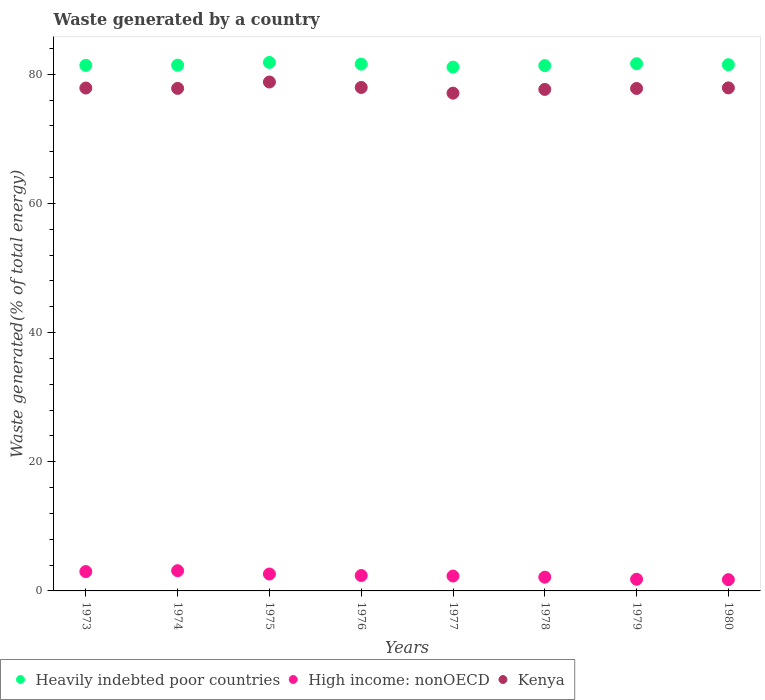How many different coloured dotlines are there?
Your response must be concise. 3. What is the total waste generated in High income: nonOECD in 1973?
Offer a terse response. 2.99. Across all years, what is the maximum total waste generated in Heavily indebted poor countries?
Provide a short and direct response. 81.84. Across all years, what is the minimum total waste generated in Kenya?
Ensure brevity in your answer.  77.08. In which year was the total waste generated in Heavily indebted poor countries maximum?
Provide a short and direct response. 1975. What is the total total waste generated in Kenya in the graph?
Your answer should be compact. 622.92. What is the difference between the total waste generated in High income: nonOECD in 1978 and that in 1980?
Ensure brevity in your answer.  0.38. What is the difference between the total waste generated in Heavily indebted poor countries in 1979 and the total waste generated in High income: nonOECD in 1976?
Keep it short and to the point. 79.26. What is the average total waste generated in Heavily indebted poor countries per year?
Make the answer very short. 81.48. In the year 1975, what is the difference between the total waste generated in Heavily indebted poor countries and total waste generated in Kenya?
Offer a terse response. 3.03. In how many years, is the total waste generated in Kenya greater than 12 %?
Your answer should be very brief. 8. What is the ratio of the total waste generated in Heavily indebted poor countries in 1973 to that in 1975?
Give a very brief answer. 0.99. What is the difference between the highest and the second highest total waste generated in Kenya?
Your response must be concise. 0.84. What is the difference between the highest and the lowest total waste generated in Kenya?
Give a very brief answer. 1.73. Is the sum of the total waste generated in Kenya in 1977 and 1978 greater than the maximum total waste generated in Heavily indebted poor countries across all years?
Your response must be concise. Yes. Is it the case that in every year, the sum of the total waste generated in Heavily indebted poor countries and total waste generated in High income: nonOECD  is greater than the total waste generated in Kenya?
Your response must be concise. Yes. Does the total waste generated in High income: nonOECD monotonically increase over the years?
Provide a succinct answer. No. Is the total waste generated in High income: nonOECD strictly greater than the total waste generated in Heavily indebted poor countries over the years?
Offer a very short reply. No. Is the total waste generated in High income: nonOECD strictly less than the total waste generated in Heavily indebted poor countries over the years?
Offer a terse response. Yes. How many dotlines are there?
Offer a terse response. 3. Where does the legend appear in the graph?
Give a very brief answer. Bottom left. How many legend labels are there?
Your answer should be compact. 3. What is the title of the graph?
Your answer should be very brief. Waste generated by a country. Does "Fragile and conflict affected situations" appear as one of the legend labels in the graph?
Offer a terse response. No. What is the label or title of the Y-axis?
Provide a succinct answer. Waste generated(% of total energy). What is the Waste generated(% of total energy) of Heavily indebted poor countries in 1973?
Provide a succinct answer. 81.39. What is the Waste generated(% of total energy) of High income: nonOECD in 1973?
Ensure brevity in your answer.  2.99. What is the Waste generated(% of total energy) of Kenya in 1973?
Make the answer very short. 77.88. What is the Waste generated(% of total energy) of Heavily indebted poor countries in 1974?
Keep it short and to the point. 81.42. What is the Waste generated(% of total energy) in High income: nonOECD in 1974?
Your answer should be compact. 3.13. What is the Waste generated(% of total energy) in Kenya in 1974?
Give a very brief answer. 77.82. What is the Waste generated(% of total energy) of Heavily indebted poor countries in 1975?
Keep it short and to the point. 81.84. What is the Waste generated(% of total energy) in High income: nonOECD in 1975?
Ensure brevity in your answer.  2.62. What is the Waste generated(% of total energy) in Kenya in 1975?
Keep it short and to the point. 78.81. What is the Waste generated(% of total energy) in Heavily indebted poor countries in 1976?
Offer a very short reply. 81.58. What is the Waste generated(% of total energy) of High income: nonOECD in 1976?
Offer a terse response. 2.38. What is the Waste generated(% of total energy) of Kenya in 1976?
Provide a succinct answer. 77.97. What is the Waste generated(% of total energy) of Heavily indebted poor countries in 1977?
Ensure brevity in your answer.  81.11. What is the Waste generated(% of total energy) of High income: nonOECD in 1977?
Your answer should be compact. 2.3. What is the Waste generated(% of total energy) in Kenya in 1977?
Make the answer very short. 77.08. What is the Waste generated(% of total energy) of Heavily indebted poor countries in 1978?
Keep it short and to the point. 81.35. What is the Waste generated(% of total energy) in High income: nonOECD in 1978?
Keep it short and to the point. 2.13. What is the Waste generated(% of total energy) in Kenya in 1978?
Your answer should be very brief. 77.66. What is the Waste generated(% of total energy) in Heavily indebted poor countries in 1979?
Offer a very short reply. 81.64. What is the Waste generated(% of total energy) of High income: nonOECD in 1979?
Give a very brief answer. 1.8. What is the Waste generated(% of total energy) in Kenya in 1979?
Provide a succinct answer. 77.81. What is the Waste generated(% of total energy) of Heavily indebted poor countries in 1980?
Ensure brevity in your answer.  81.49. What is the Waste generated(% of total energy) of High income: nonOECD in 1980?
Ensure brevity in your answer.  1.75. What is the Waste generated(% of total energy) in Kenya in 1980?
Provide a succinct answer. 77.9. Across all years, what is the maximum Waste generated(% of total energy) of Heavily indebted poor countries?
Your response must be concise. 81.84. Across all years, what is the maximum Waste generated(% of total energy) of High income: nonOECD?
Your response must be concise. 3.13. Across all years, what is the maximum Waste generated(% of total energy) in Kenya?
Keep it short and to the point. 78.81. Across all years, what is the minimum Waste generated(% of total energy) of Heavily indebted poor countries?
Make the answer very short. 81.11. Across all years, what is the minimum Waste generated(% of total energy) of High income: nonOECD?
Give a very brief answer. 1.75. Across all years, what is the minimum Waste generated(% of total energy) in Kenya?
Provide a short and direct response. 77.08. What is the total Waste generated(% of total energy) in Heavily indebted poor countries in the graph?
Offer a very short reply. 651.8. What is the total Waste generated(% of total energy) of High income: nonOECD in the graph?
Give a very brief answer. 19.11. What is the total Waste generated(% of total energy) in Kenya in the graph?
Provide a succinct answer. 622.92. What is the difference between the Waste generated(% of total energy) in Heavily indebted poor countries in 1973 and that in 1974?
Your answer should be very brief. -0.03. What is the difference between the Waste generated(% of total energy) of High income: nonOECD in 1973 and that in 1974?
Keep it short and to the point. -0.14. What is the difference between the Waste generated(% of total energy) of Kenya in 1973 and that in 1974?
Make the answer very short. 0.06. What is the difference between the Waste generated(% of total energy) in Heavily indebted poor countries in 1973 and that in 1975?
Make the answer very short. -0.45. What is the difference between the Waste generated(% of total energy) in High income: nonOECD in 1973 and that in 1975?
Offer a very short reply. 0.38. What is the difference between the Waste generated(% of total energy) in Kenya in 1973 and that in 1975?
Your answer should be compact. -0.93. What is the difference between the Waste generated(% of total energy) in Heavily indebted poor countries in 1973 and that in 1976?
Your answer should be compact. -0.19. What is the difference between the Waste generated(% of total energy) in High income: nonOECD in 1973 and that in 1976?
Offer a very short reply. 0.61. What is the difference between the Waste generated(% of total energy) in Kenya in 1973 and that in 1976?
Provide a short and direct response. -0.09. What is the difference between the Waste generated(% of total energy) in Heavily indebted poor countries in 1973 and that in 1977?
Your answer should be very brief. 0.27. What is the difference between the Waste generated(% of total energy) of High income: nonOECD in 1973 and that in 1977?
Keep it short and to the point. 0.69. What is the difference between the Waste generated(% of total energy) of Kenya in 1973 and that in 1977?
Give a very brief answer. 0.8. What is the difference between the Waste generated(% of total energy) in Heavily indebted poor countries in 1973 and that in 1978?
Your answer should be very brief. 0.04. What is the difference between the Waste generated(% of total energy) of High income: nonOECD in 1973 and that in 1978?
Ensure brevity in your answer.  0.87. What is the difference between the Waste generated(% of total energy) of Kenya in 1973 and that in 1978?
Offer a terse response. 0.22. What is the difference between the Waste generated(% of total energy) of Heavily indebted poor countries in 1973 and that in 1979?
Your response must be concise. -0.26. What is the difference between the Waste generated(% of total energy) of High income: nonOECD in 1973 and that in 1979?
Provide a succinct answer. 1.19. What is the difference between the Waste generated(% of total energy) of Kenya in 1973 and that in 1979?
Your response must be concise. 0.07. What is the difference between the Waste generated(% of total energy) of Heavily indebted poor countries in 1973 and that in 1980?
Ensure brevity in your answer.  -0.1. What is the difference between the Waste generated(% of total energy) in High income: nonOECD in 1973 and that in 1980?
Ensure brevity in your answer.  1.25. What is the difference between the Waste generated(% of total energy) of Kenya in 1973 and that in 1980?
Your answer should be compact. -0.02. What is the difference between the Waste generated(% of total energy) of Heavily indebted poor countries in 1974 and that in 1975?
Make the answer very short. -0.42. What is the difference between the Waste generated(% of total energy) in High income: nonOECD in 1974 and that in 1975?
Offer a very short reply. 0.51. What is the difference between the Waste generated(% of total energy) of Kenya in 1974 and that in 1975?
Ensure brevity in your answer.  -0.99. What is the difference between the Waste generated(% of total energy) in Heavily indebted poor countries in 1974 and that in 1976?
Give a very brief answer. -0.16. What is the difference between the Waste generated(% of total energy) in Kenya in 1974 and that in 1976?
Your answer should be very brief. -0.15. What is the difference between the Waste generated(% of total energy) of Heavily indebted poor countries in 1974 and that in 1977?
Make the answer very short. 0.3. What is the difference between the Waste generated(% of total energy) of High income: nonOECD in 1974 and that in 1977?
Offer a very short reply. 0.83. What is the difference between the Waste generated(% of total energy) in Kenya in 1974 and that in 1977?
Provide a succinct answer. 0.74. What is the difference between the Waste generated(% of total energy) of Heavily indebted poor countries in 1974 and that in 1978?
Keep it short and to the point. 0.07. What is the difference between the Waste generated(% of total energy) of High income: nonOECD in 1974 and that in 1978?
Your response must be concise. 1. What is the difference between the Waste generated(% of total energy) of Kenya in 1974 and that in 1978?
Provide a short and direct response. 0.16. What is the difference between the Waste generated(% of total energy) of Heavily indebted poor countries in 1974 and that in 1979?
Keep it short and to the point. -0.23. What is the difference between the Waste generated(% of total energy) in High income: nonOECD in 1974 and that in 1979?
Provide a short and direct response. 1.33. What is the difference between the Waste generated(% of total energy) of Kenya in 1974 and that in 1979?
Give a very brief answer. 0.01. What is the difference between the Waste generated(% of total energy) of Heavily indebted poor countries in 1974 and that in 1980?
Keep it short and to the point. -0.07. What is the difference between the Waste generated(% of total energy) in High income: nonOECD in 1974 and that in 1980?
Provide a short and direct response. 1.39. What is the difference between the Waste generated(% of total energy) of Kenya in 1974 and that in 1980?
Make the answer very short. -0.08. What is the difference between the Waste generated(% of total energy) in Heavily indebted poor countries in 1975 and that in 1976?
Offer a terse response. 0.26. What is the difference between the Waste generated(% of total energy) in High income: nonOECD in 1975 and that in 1976?
Provide a succinct answer. 0.24. What is the difference between the Waste generated(% of total energy) of Kenya in 1975 and that in 1976?
Offer a very short reply. 0.84. What is the difference between the Waste generated(% of total energy) in Heavily indebted poor countries in 1975 and that in 1977?
Give a very brief answer. 0.73. What is the difference between the Waste generated(% of total energy) in High income: nonOECD in 1975 and that in 1977?
Give a very brief answer. 0.31. What is the difference between the Waste generated(% of total energy) in Kenya in 1975 and that in 1977?
Provide a short and direct response. 1.73. What is the difference between the Waste generated(% of total energy) of Heavily indebted poor countries in 1975 and that in 1978?
Ensure brevity in your answer.  0.49. What is the difference between the Waste generated(% of total energy) of High income: nonOECD in 1975 and that in 1978?
Ensure brevity in your answer.  0.49. What is the difference between the Waste generated(% of total energy) of Kenya in 1975 and that in 1978?
Offer a very short reply. 1.15. What is the difference between the Waste generated(% of total energy) of Heavily indebted poor countries in 1975 and that in 1979?
Your response must be concise. 0.2. What is the difference between the Waste generated(% of total energy) in High income: nonOECD in 1975 and that in 1979?
Provide a short and direct response. 0.82. What is the difference between the Waste generated(% of total energy) of Heavily indebted poor countries in 1975 and that in 1980?
Offer a very short reply. 0.35. What is the difference between the Waste generated(% of total energy) in High income: nonOECD in 1975 and that in 1980?
Your answer should be very brief. 0.87. What is the difference between the Waste generated(% of total energy) in Kenya in 1975 and that in 1980?
Make the answer very short. 0.91. What is the difference between the Waste generated(% of total energy) in Heavily indebted poor countries in 1976 and that in 1977?
Provide a succinct answer. 0.46. What is the difference between the Waste generated(% of total energy) of High income: nonOECD in 1976 and that in 1977?
Provide a short and direct response. 0.08. What is the difference between the Waste generated(% of total energy) of Kenya in 1976 and that in 1977?
Make the answer very short. 0.88. What is the difference between the Waste generated(% of total energy) in Heavily indebted poor countries in 1976 and that in 1978?
Provide a succinct answer. 0.23. What is the difference between the Waste generated(% of total energy) of High income: nonOECD in 1976 and that in 1978?
Offer a terse response. 0.25. What is the difference between the Waste generated(% of total energy) of Kenya in 1976 and that in 1978?
Your answer should be compact. 0.3. What is the difference between the Waste generated(% of total energy) in Heavily indebted poor countries in 1976 and that in 1979?
Provide a short and direct response. -0.07. What is the difference between the Waste generated(% of total energy) of High income: nonOECD in 1976 and that in 1979?
Provide a short and direct response. 0.58. What is the difference between the Waste generated(% of total energy) in Kenya in 1976 and that in 1979?
Give a very brief answer. 0.16. What is the difference between the Waste generated(% of total energy) in Heavily indebted poor countries in 1976 and that in 1980?
Keep it short and to the point. 0.09. What is the difference between the Waste generated(% of total energy) in High income: nonOECD in 1976 and that in 1980?
Make the answer very short. 0.64. What is the difference between the Waste generated(% of total energy) of Kenya in 1976 and that in 1980?
Offer a terse response. 0.07. What is the difference between the Waste generated(% of total energy) in Heavily indebted poor countries in 1977 and that in 1978?
Make the answer very short. -0.24. What is the difference between the Waste generated(% of total energy) of High income: nonOECD in 1977 and that in 1978?
Your response must be concise. 0.18. What is the difference between the Waste generated(% of total energy) of Kenya in 1977 and that in 1978?
Your response must be concise. -0.58. What is the difference between the Waste generated(% of total energy) in Heavily indebted poor countries in 1977 and that in 1979?
Keep it short and to the point. -0.53. What is the difference between the Waste generated(% of total energy) in High income: nonOECD in 1977 and that in 1979?
Your answer should be very brief. 0.5. What is the difference between the Waste generated(% of total energy) in Kenya in 1977 and that in 1979?
Offer a very short reply. -0.73. What is the difference between the Waste generated(% of total energy) of Heavily indebted poor countries in 1977 and that in 1980?
Offer a terse response. -0.37. What is the difference between the Waste generated(% of total energy) in High income: nonOECD in 1977 and that in 1980?
Your answer should be compact. 0.56. What is the difference between the Waste generated(% of total energy) in Kenya in 1977 and that in 1980?
Your answer should be very brief. -0.82. What is the difference between the Waste generated(% of total energy) in Heavily indebted poor countries in 1978 and that in 1979?
Your answer should be very brief. -0.29. What is the difference between the Waste generated(% of total energy) in High income: nonOECD in 1978 and that in 1979?
Give a very brief answer. 0.33. What is the difference between the Waste generated(% of total energy) in Kenya in 1978 and that in 1979?
Provide a short and direct response. -0.15. What is the difference between the Waste generated(% of total energy) of Heavily indebted poor countries in 1978 and that in 1980?
Offer a terse response. -0.14. What is the difference between the Waste generated(% of total energy) of High income: nonOECD in 1978 and that in 1980?
Make the answer very short. 0.38. What is the difference between the Waste generated(% of total energy) of Kenya in 1978 and that in 1980?
Make the answer very short. -0.24. What is the difference between the Waste generated(% of total energy) in Heavily indebted poor countries in 1979 and that in 1980?
Your response must be concise. 0.15. What is the difference between the Waste generated(% of total energy) in High income: nonOECD in 1979 and that in 1980?
Keep it short and to the point. 0.05. What is the difference between the Waste generated(% of total energy) in Kenya in 1979 and that in 1980?
Keep it short and to the point. -0.09. What is the difference between the Waste generated(% of total energy) in Heavily indebted poor countries in 1973 and the Waste generated(% of total energy) in High income: nonOECD in 1974?
Your response must be concise. 78.25. What is the difference between the Waste generated(% of total energy) of Heavily indebted poor countries in 1973 and the Waste generated(% of total energy) of Kenya in 1974?
Your response must be concise. 3.57. What is the difference between the Waste generated(% of total energy) of High income: nonOECD in 1973 and the Waste generated(% of total energy) of Kenya in 1974?
Ensure brevity in your answer.  -74.82. What is the difference between the Waste generated(% of total energy) in Heavily indebted poor countries in 1973 and the Waste generated(% of total energy) in High income: nonOECD in 1975?
Your answer should be compact. 78.77. What is the difference between the Waste generated(% of total energy) of Heavily indebted poor countries in 1973 and the Waste generated(% of total energy) of Kenya in 1975?
Offer a very short reply. 2.58. What is the difference between the Waste generated(% of total energy) of High income: nonOECD in 1973 and the Waste generated(% of total energy) of Kenya in 1975?
Make the answer very short. -75.81. What is the difference between the Waste generated(% of total energy) in Heavily indebted poor countries in 1973 and the Waste generated(% of total energy) in High income: nonOECD in 1976?
Keep it short and to the point. 79. What is the difference between the Waste generated(% of total energy) in Heavily indebted poor countries in 1973 and the Waste generated(% of total energy) in Kenya in 1976?
Make the answer very short. 3.42. What is the difference between the Waste generated(% of total energy) of High income: nonOECD in 1973 and the Waste generated(% of total energy) of Kenya in 1976?
Provide a succinct answer. -74.97. What is the difference between the Waste generated(% of total energy) of Heavily indebted poor countries in 1973 and the Waste generated(% of total energy) of High income: nonOECD in 1977?
Provide a short and direct response. 79.08. What is the difference between the Waste generated(% of total energy) of Heavily indebted poor countries in 1973 and the Waste generated(% of total energy) of Kenya in 1977?
Ensure brevity in your answer.  4.3. What is the difference between the Waste generated(% of total energy) of High income: nonOECD in 1973 and the Waste generated(% of total energy) of Kenya in 1977?
Your answer should be very brief. -74.09. What is the difference between the Waste generated(% of total energy) in Heavily indebted poor countries in 1973 and the Waste generated(% of total energy) in High income: nonOECD in 1978?
Your answer should be compact. 79.26. What is the difference between the Waste generated(% of total energy) of Heavily indebted poor countries in 1973 and the Waste generated(% of total energy) of Kenya in 1978?
Your answer should be compact. 3.72. What is the difference between the Waste generated(% of total energy) of High income: nonOECD in 1973 and the Waste generated(% of total energy) of Kenya in 1978?
Your answer should be very brief. -74.67. What is the difference between the Waste generated(% of total energy) of Heavily indebted poor countries in 1973 and the Waste generated(% of total energy) of High income: nonOECD in 1979?
Give a very brief answer. 79.58. What is the difference between the Waste generated(% of total energy) in Heavily indebted poor countries in 1973 and the Waste generated(% of total energy) in Kenya in 1979?
Provide a succinct answer. 3.58. What is the difference between the Waste generated(% of total energy) in High income: nonOECD in 1973 and the Waste generated(% of total energy) in Kenya in 1979?
Your response must be concise. -74.81. What is the difference between the Waste generated(% of total energy) in Heavily indebted poor countries in 1973 and the Waste generated(% of total energy) in High income: nonOECD in 1980?
Provide a succinct answer. 79.64. What is the difference between the Waste generated(% of total energy) of Heavily indebted poor countries in 1973 and the Waste generated(% of total energy) of Kenya in 1980?
Provide a succinct answer. 3.49. What is the difference between the Waste generated(% of total energy) in High income: nonOECD in 1973 and the Waste generated(% of total energy) in Kenya in 1980?
Provide a succinct answer. -74.9. What is the difference between the Waste generated(% of total energy) of Heavily indebted poor countries in 1974 and the Waste generated(% of total energy) of High income: nonOECD in 1975?
Ensure brevity in your answer.  78.8. What is the difference between the Waste generated(% of total energy) of Heavily indebted poor countries in 1974 and the Waste generated(% of total energy) of Kenya in 1975?
Your answer should be very brief. 2.61. What is the difference between the Waste generated(% of total energy) of High income: nonOECD in 1974 and the Waste generated(% of total energy) of Kenya in 1975?
Provide a succinct answer. -75.68. What is the difference between the Waste generated(% of total energy) in Heavily indebted poor countries in 1974 and the Waste generated(% of total energy) in High income: nonOECD in 1976?
Your answer should be compact. 79.03. What is the difference between the Waste generated(% of total energy) in Heavily indebted poor countries in 1974 and the Waste generated(% of total energy) in Kenya in 1976?
Your response must be concise. 3.45. What is the difference between the Waste generated(% of total energy) in High income: nonOECD in 1974 and the Waste generated(% of total energy) in Kenya in 1976?
Keep it short and to the point. -74.83. What is the difference between the Waste generated(% of total energy) of Heavily indebted poor countries in 1974 and the Waste generated(% of total energy) of High income: nonOECD in 1977?
Offer a very short reply. 79.11. What is the difference between the Waste generated(% of total energy) in Heavily indebted poor countries in 1974 and the Waste generated(% of total energy) in Kenya in 1977?
Provide a short and direct response. 4.33. What is the difference between the Waste generated(% of total energy) in High income: nonOECD in 1974 and the Waste generated(% of total energy) in Kenya in 1977?
Your response must be concise. -73.95. What is the difference between the Waste generated(% of total energy) of Heavily indebted poor countries in 1974 and the Waste generated(% of total energy) of High income: nonOECD in 1978?
Provide a short and direct response. 79.29. What is the difference between the Waste generated(% of total energy) of Heavily indebted poor countries in 1974 and the Waste generated(% of total energy) of Kenya in 1978?
Ensure brevity in your answer.  3.76. What is the difference between the Waste generated(% of total energy) of High income: nonOECD in 1974 and the Waste generated(% of total energy) of Kenya in 1978?
Give a very brief answer. -74.53. What is the difference between the Waste generated(% of total energy) in Heavily indebted poor countries in 1974 and the Waste generated(% of total energy) in High income: nonOECD in 1979?
Your answer should be very brief. 79.62. What is the difference between the Waste generated(% of total energy) in Heavily indebted poor countries in 1974 and the Waste generated(% of total energy) in Kenya in 1979?
Your answer should be very brief. 3.61. What is the difference between the Waste generated(% of total energy) of High income: nonOECD in 1974 and the Waste generated(% of total energy) of Kenya in 1979?
Offer a very short reply. -74.68. What is the difference between the Waste generated(% of total energy) of Heavily indebted poor countries in 1974 and the Waste generated(% of total energy) of High income: nonOECD in 1980?
Your answer should be very brief. 79.67. What is the difference between the Waste generated(% of total energy) of Heavily indebted poor countries in 1974 and the Waste generated(% of total energy) of Kenya in 1980?
Give a very brief answer. 3.52. What is the difference between the Waste generated(% of total energy) of High income: nonOECD in 1974 and the Waste generated(% of total energy) of Kenya in 1980?
Provide a short and direct response. -74.77. What is the difference between the Waste generated(% of total energy) of Heavily indebted poor countries in 1975 and the Waste generated(% of total energy) of High income: nonOECD in 1976?
Your answer should be very brief. 79.46. What is the difference between the Waste generated(% of total energy) of Heavily indebted poor countries in 1975 and the Waste generated(% of total energy) of Kenya in 1976?
Offer a terse response. 3.87. What is the difference between the Waste generated(% of total energy) of High income: nonOECD in 1975 and the Waste generated(% of total energy) of Kenya in 1976?
Offer a terse response. -75.35. What is the difference between the Waste generated(% of total energy) in Heavily indebted poor countries in 1975 and the Waste generated(% of total energy) in High income: nonOECD in 1977?
Your answer should be compact. 79.53. What is the difference between the Waste generated(% of total energy) in Heavily indebted poor countries in 1975 and the Waste generated(% of total energy) in Kenya in 1977?
Offer a terse response. 4.76. What is the difference between the Waste generated(% of total energy) in High income: nonOECD in 1975 and the Waste generated(% of total energy) in Kenya in 1977?
Keep it short and to the point. -74.46. What is the difference between the Waste generated(% of total energy) of Heavily indebted poor countries in 1975 and the Waste generated(% of total energy) of High income: nonOECD in 1978?
Give a very brief answer. 79.71. What is the difference between the Waste generated(% of total energy) in Heavily indebted poor countries in 1975 and the Waste generated(% of total energy) in Kenya in 1978?
Provide a succinct answer. 4.18. What is the difference between the Waste generated(% of total energy) of High income: nonOECD in 1975 and the Waste generated(% of total energy) of Kenya in 1978?
Offer a terse response. -75.04. What is the difference between the Waste generated(% of total energy) of Heavily indebted poor countries in 1975 and the Waste generated(% of total energy) of High income: nonOECD in 1979?
Your response must be concise. 80.04. What is the difference between the Waste generated(% of total energy) of Heavily indebted poor countries in 1975 and the Waste generated(% of total energy) of Kenya in 1979?
Keep it short and to the point. 4.03. What is the difference between the Waste generated(% of total energy) of High income: nonOECD in 1975 and the Waste generated(% of total energy) of Kenya in 1979?
Give a very brief answer. -75.19. What is the difference between the Waste generated(% of total energy) of Heavily indebted poor countries in 1975 and the Waste generated(% of total energy) of High income: nonOECD in 1980?
Keep it short and to the point. 80.09. What is the difference between the Waste generated(% of total energy) of Heavily indebted poor countries in 1975 and the Waste generated(% of total energy) of Kenya in 1980?
Your answer should be very brief. 3.94. What is the difference between the Waste generated(% of total energy) of High income: nonOECD in 1975 and the Waste generated(% of total energy) of Kenya in 1980?
Make the answer very short. -75.28. What is the difference between the Waste generated(% of total energy) of Heavily indebted poor countries in 1976 and the Waste generated(% of total energy) of High income: nonOECD in 1977?
Keep it short and to the point. 79.27. What is the difference between the Waste generated(% of total energy) in Heavily indebted poor countries in 1976 and the Waste generated(% of total energy) in Kenya in 1977?
Keep it short and to the point. 4.49. What is the difference between the Waste generated(% of total energy) in High income: nonOECD in 1976 and the Waste generated(% of total energy) in Kenya in 1977?
Ensure brevity in your answer.  -74.7. What is the difference between the Waste generated(% of total energy) in Heavily indebted poor countries in 1976 and the Waste generated(% of total energy) in High income: nonOECD in 1978?
Your response must be concise. 79.45. What is the difference between the Waste generated(% of total energy) in Heavily indebted poor countries in 1976 and the Waste generated(% of total energy) in Kenya in 1978?
Your answer should be very brief. 3.91. What is the difference between the Waste generated(% of total energy) of High income: nonOECD in 1976 and the Waste generated(% of total energy) of Kenya in 1978?
Your answer should be very brief. -75.28. What is the difference between the Waste generated(% of total energy) of Heavily indebted poor countries in 1976 and the Waste generated(% of total energy) of High income: nonOECD in 1979?
Provide a short and direct response. 79.77. What is the difference between the Waste generated(% of total energy) in Heavily indebted poor countries in 1976 and the Waste generated(% of total energy) in Kenya in 1979?
Ensure brevity in your answer.  3.77. What is the difference between the Waste generated(% of total energy) of High income: nonOECD in 1976 and the Waste generated(% of total energy) of Kenya in 1979?
Provide a short and direct response. -75.43. What is the difference between the Waste generated(% of total energy) in Heavily indebted poor countries in 1976 and the Waste generated(% of total energy) in High income: nonOECD in 1980?
Your answer should be very brief. 79.83. What is the difference between the Waste generated(% of total energy) in Heavily indebted poor countries in 1976 and the Waste generated(% of total energy) in Kenya in 1980?
Give a very brief answer. 3.68. What is the difference between the Waste generated(% of total energy) in High income: nonOECD in 1976 and the Waste generated(% of total energy) in Kenya in 1980?
Your answer should be very brief. -75.52. What is the difference between the Waste generated(% of total energy) of Heavily indebted poor countries in 1977 and the Waste generated(% of total energy) of High income: nonOECD in 1978?
Your response must be concise. 78.98. What is the difference between the Waste generated(% of total energy) in Heavily indebted poor countries in 1977 and the Waste generated(% of total energy) in Kenya in 1978?
Provide a short and direct response. 3.45. What is the difference between the Waste generated(% of total energy) in High income: nonOECD in 1977 and the Waste generated(% of total energy) in Kenya in 1978?
Provide a succinct answer. -75.36. What is the difference between the Waste generated(% of total energy) in Heavily indebted poor countries in 1977 and the Waste generated(% of total energy) in High income: nonOECD in 1979?
Your answer should be compact. 79.31. What is the difference between the Waste generated(% of total energy) in Heavily indebted poor countries in 1977 and the Waste generated(% of total energy) in Kenya in 1979?
Offer a terse response. 3.3. What is the difference between the Waste generated(% of total energy) of High income: nonOECD in 1977 and the Waste generated(% of total energy) of Kenya in 1979?
Your answer should be very brief. -75.5. What is the difference between the Waste generated(% of total energy) in Heavily indebted poor countries in 1977 and the Waste generated(% of total energy) in High income: nonOECD in 1980?
Your answer should be very brief. 79.37. What is the difference between the Waste generated(% of total energy) in Heavily indebted poor countries in 1977 and the Waste generated(% of total energy) in Kenya in 1980?
Offer a terse response. 3.21. What is the difference between the Waste generated(% of total energy) of High income: nonOECD in 1977 and the Waste generated(% of total energy) of Kenya in 1980?
Make the answer very short. -75.59. What is the difference between the Waste generated(% of total energy) in Heavily indebted poor countries in 1978 and the Waste generated(% of total energy) in High income: nonOECD in 1979?
Your answer should be compact. 79.55. What is the difference between the Waste generated(% of total energy) of Heavily indebted poor countries in 1978 and the Waste generated(% of total energy) of Kenya in 1979?
Make the answer very short. 3.54. What is the difference between the Waste generated(% of total energy) of High income: nonOECD in 1978 and the Waste generated(% of total energy) of Kenya in 1979?
Offer a terse response. -75.68. What is the difference between the Waste generated(% of total energy) of Heavily indebted poor countries in 1978 and the Waste generated(% of total energy) of High income: nonOECD in 1980?
Offer a very short reply. 79.6. What is the difference between the Waste generated(% of total energy) in Heavily indebted poor countries in 1978 and the Waste generated(% of total energy) in Kenya in 1980?
Offer a terse response. 3.45. What is the difference between the Waste generated(% of total energy) in High income: nonOECD in 1978 and the Waste generated(% of total energy) in Kenya in 1980?
Give a very brief answer. -75.77. What is the difference between the Waste generated(% of total energy) in Heavily indebted poor countries in 1979 and the Waste generated(% of total energy) in High income: nonOECD in 1980?
Keep it short and to the point. 79.9. What is the difference between the Waste generated(% of total energy) of Heavily indebted poor countries in 1979 and the Waste generated(% of total energy) of Kenya in 1980?
Your response must be concise. 3.74. What is the difference between the Waste generated(% of total energy) in High income: nonOECD in 1979 and the Waste generated(% of total energy) in Kenya in 1980?
Offer a very short reply. -76.1. What is the average Waste generated(% of total energy) of Heavily indebted poor countries per year?
Your response must be concise. 81.48. What is the average Waste generated(% of total energy) in High income: nonOECD per year?
Your answer should be compact. 2.39. What is the average Waste generated(% of total energy) of Kenya per year?
Your response must be concise. 77.86. In the year 1973, what is the difference between the Waste generated(% of total energy) in Heavily indebted poor countries and Waste generated(% of total energy) in High income: nonOECD?
Offer a very short reply. 78.39. In the year 1973, what is the difference between the Waste generated(% of total energy) in Heavily indebted poor countries and Waste generated(% of total energy) in Kenya?
Provide a succinct answer. 3.51. In the year 1973, what is the difference between the Waste generated(% of total energy) in High income: nonOECD and Waste generated(% of total energy) in Kenya?
Make the answer very short. -74.88. In the year 1974, what is the difference between the Waste generated(% of total energy) in Heavily indebted poor countries and Waste generated(% of total energy) in High income: nonOECD?
Offer a terse response. 78.28. In the year 1974, what is the difference between the Waste generated(% of total energy) of Heavily indebted poor countries and Waste generated(% of total energy) of Kenya?
Offer a terse response. 3.6. In the year 1974, what is the difference between the Waste generated(% of total energy) of High income: nonOECD and Waste generated(% of total energy) of Kenya?
Give a very brief answer. -74.69. In the year 1975, what is the difference between the Waste generated(% of total energy) of Heavily indebted poor countries and Waste generated(% of total energy) of High income: nonOECD?
Your response must be concise. 79.22. In the year 1975, what is the difference between the Waste generated(% of total energy) of Heavily indebted poor countries and Waste generated(% of total energy) of Kenya?
Offer a terse response. 3.03. In the year 1975, what is the difference between the Waste generated(% of total energy) in High income: nonOECD and Waste generated(% of total energy) in Kenya?
Keep it short and to the point. -76.19. In the year 1976, what is the difference between the Waste generated(% of total energy) in Heavily indebted poor countries and Waste generated(% of total energy) in High income: nonOECD?
Give a very brief answer. 79.19. In the year 1976, what is the difference between the Waste generated(% of total energy) in Heavily indebted poor countries and Waste generated(% of total energy) in Kenya?
Offer a very short reply. 3.61. In the year 1976, what is the difference between the Waste generated(% of total energy) in High income: nonOECD and Waste generated(% of total energy) in Kenya?
Your answer should be very brief. -75.58. In the year 1977, what is the difference between the Waste generated(% of total energy) in Heavily indebted poor countries and Waste generated(% of total energy) in High income: nonOECD?
Offer a very short reply. 78.81. In the year 1977, what is the difference between the Waste generated(% of total energy) of Heavily indebted poor countries and Waste generated(% of total energy) of Kenya?
Keep it short and to the point. 4.03. In the year 1977, what is the difference between the Waste generated(% of total energy) in High income: nonOECD and Waste generated(% of total energy) in Kenya?
Provide a short and direct response. -74.78. In the year 1978, what is the difference between the Waste generated(% of total energy) of Heavily indebted poor countries and Waste generated(% of total energy) of High income: nonOECD?
Ensure brevity in your answer.  79.22. In the year 1978, what is the difference between the Waste generated(% of total energy) in Heavily indebted poor countries and Waste generated(% of total energy) in Kenya?
Give a very brief answer. 3.69. In the year 1978, what is the difference between the Waste generated(% of total energy) of High income: nonOECD and Waste generated(% of total energy) of Kenya?
Make the answer very short. -75.53. In the year 1979, what is the difference between the Waste generated(% of total energy) of Heavily indebted poor countries and Waste generated(% of total energy) of High income: nonOECD?
Your answer should be very brief. 79.84. In the year 1979, what is the difference between the Waste generated(% of total energy) in Heavily indebted poor countries and Waste generated(% of total energy) in Kenya?
Give a very brief answer. 3.83. In the year 1979, what is the difference between the Waste generated(% of total energy) in High income: nonOECD and Waste generated(% of total energy) in Kenya?
Your answer should be compact. -76.01. In the year 1980, what is the difference between the Waste generated(% of total energy) in Heavily indebted poor countries and Waste generated(% of total energy) in High income: nonOECD?
Offer a terse response. 79.74. In the year 1980, what is the difference between the Waste generated(% of total energy) of Heavily indebted poor countries and Waste generated(% of total energy) of Kenya?
Offer a terse response. 3.59. In the year 1980, what is the difference between the Waste generated(% of total energy) of High income: nonOECD and Waste generated(% of total energy) of Kenya?
Provide a short and direct response. -76.15. What is the ratio of the Waste generated(% of total energy) of Heavily indebted poor countries in 1973 to that in 1974?
Your answer should be compact. 1. What is the ratio of the Waste generated(% of total energy) of High income: nonOECD in 1973 to that in 1974?
Provide a succinct answer. 0.96. What is the ratio of the Waste generated(% of total energy) of Kenya in 1973 to that in 1974?
Offer a very short reply. 1. What is the ratio of the Waste generated(% of total energy) in High income: nonOECD in 1973 to that in 1975?
Provide a short and direct response. 1.14. What is the ratio of the Waste generated(% of total energy) of High income: nonOECD in 1973 to that in 1976?
Your response must be concise. 1.26. What is the ratio of the Waste generated(% of total energy) of Heavily indebted poor countries in 1973 to that in 1977?
Provide a succinct answer. 1. What is the ratio of the Waste generated(% of total energy) of High income: nonOECD in 1973 to that in 1977?
Keep it short and to the point. 1.3. What is the ratio of the Waste generated(% of total energy) in Kenya in 1973 to that in 1977?
Give a very brief answer. 1.01. What is the ratio of the Waste generated(% of total energy) of High income: nonOECD in 1973 to that in 1978?
Provide a succinct answer. 1.41. What is the ratio of the Waste generated(% of total energy) in Heavily indebted poor countries in 1973 to that in 1979?
Offer a very short reply. 1. What is the ratio of the Waste generated(% of total energy) of High income: nonOECD in 1973 to that in 1979?
Provide a succinct answer. 1.66. What is the ratio of the Waste generated(% of total energy) of High income: nonOECD in 1973 to that in 1980?
Ensure brevity in your answer.  1.72. What is the ratio of the Waste generated(% of total energy) of Kenya in 1973 to that in 1980?
Your answer should be compact. 1. What is the ratio of the Waste generated(% of total energy) of Heavily indebted poor countries in 1974 to that in 1975?
Your answer should be compact. 0.99. What is the ratio of the Waste generated(% of total energy) in High income: nonOECD in 1974 to that in 1975?
Your answer should be very brief. 1.2. What is the ratio of the Waste generated(% of total energy) of Kenya in 1974 to that in 1975?
Offer a terse response. 0.99. What is the ratio of the Waste generated(% of total energy) in High income: nonOECD in 1974 to that in 1976?
Your response must be concise. 1.31. What is the ratio of the Waste generated(% of total energy) in Kenya in 1974 to that in 1976?
Give a very brief answer. 1. What is the ratio of the Waste generated(% of total energy) in High income: nonOECD in 1974 to that in 1977?
Provide a short and direct response. 1.36. What is the ratio of the Waste generated(% of total energy) in Kenya in 1974 to that in 1977?
Your answer should be very brief. 1.01. What is the ratio of the Waste generated(% of total energy) in Heavily indebted poor countries in 1974 to that in 1978?
Ensure brevity in your answer.  1. What is the ratio of the Waste generated(% of total energy) in High income: nonOECD in 1974 to that in 1978?
Make the answer very short. 1.47. What is the ratio of the Waste generated(% of total energy) of Heavily indebted poor countries in 1974 to that in 1979?
Offer a very short reply. 1. What is the ratio of the Waste generated(% of total energy) in High income: nonOECD in 1974 to that in 1979?
Offer a very short reply. 1.74. What is the ratio of the Waste generated(% of total energy) of Kenya in 1974 to that in 1979?
Ensure brevity in your answer.  1. What is the ratio of the Waste generated(% of total energy) of High income: nonOECD in 1974 to that in 1980?
Your response must be concise. 1.79. What is the ratio of the Waste generated(% of total energy) of High income: nonOECD in 1975 to that in 1976?
Your response must be concise. 1.1. What is the ratio of the Waste generated(% of total energy) in Kenya in 1975 to that in 1976?
Make the answer very short. 1.01. What is the ratio of the Waste generated(% of total energy) in Heavily indebted poor countries in 1975 to that in 1977?
Provide a short and direct response. 1.01. What is the ratio of the Waste generated(% of total energy) in High income: nonOECD in 1975 to that in 1977?
Offer a terse response. 1.14. What is the ratio of the Waste generated(% of total energy) of Kenya in 1975 to that in 1977?
Your answer should be very brief. 1.02. What is the ratio of the Waste generated(% of total energy) of Heavily indebted poor countries in 1975 to that in 1978?
Your answer should be compact. 1.01. What is the ratio of the Waste generated(% of total energy) of High income: nonOECD in 1975 to that in 1978?
Offer a terse response. 1.23. What is the ratio of the Waste generated(% of total energy) in Kenya in 1975 to that in 1978?
Your answer should be very brief. 1.01. What is the ratio of the Waste generated(% of total energy) in Heavily indebted poor countries in 1975 to that in 1979?
Give a very brief answer. 1. What is the ratio of the Waste generated(% of total energy) in High income: nonOECD in 1975 to that in 1979?
Give a very brief answer. 1.45. What is the ratio of the Waste generated(% of total energy) in Kenya in 1975 to that in 1979?
Your answer should be very brief. 1.01. What is the ratio of the Waste generated(% of total energy) in Heavily indebted poor countries in 1975 to that in 1980?
Your response must be concise. 1. What is the ratio of the Waste generated(% of total energy) of High income: nonOECD in 1975 to that in 1980?
Keep it short and to the point. 1.5. What is the ratio of the Waste generated(% of total energy) in Kenya in 1975 to that in 1980?
Keep it short and to the point. 1.01. What is the ratio of the Waste generated(% of total energy) of Heavily indebted poor countries in 1976 to that in 1977?
Offer a very short reply. 1.01. What is the ratio of the Waste generated(% of total energy) in Kenya in 1976 to that in 1977?
Offer a very short reply. 1.01. What is the ratio of the Waste generated(% of total energy) of High income: nonOECD in 1976 to that in 1978?
Make the answer very short. 1.12. What is the ratio of the Waste generated(% of total energy) of High income: nonOECD in 1976 to that in 1979?
Give a very brief answer. 1.32. What is the ratio of the Waste generated(% of total energy) in Kenya in 1976 to that in 1979?
Keep it short and to the point. 1. What is the ratio of the Waste generated(% of total energy) of Heavily indebted poor countries in 1976 to that in 1980?
Keep it short and to the point. 1. What is the ratio of the Waste generated(% of total energy) of High income: nonOECD in 1976 to that in 1980?
Your answer should be compact. 1.36. What is the ratio of the Waste generated(% of total energy) of High income: nonOECD in 1977 to that in 1978?
Provide a short and direct response. 1.08. What is the ratio of the Waste generated(% of total energy) in High income: nonOECD in 1977 to that in 1979?
Your answer should be very brief. 1.28. What is the ratio of the Waste generated(% of total energy) in Kenya in 1977 to that in 1979?
Your answer should be compact. 0.99. What is the ratio of the Waste generated(% of total energy) of Heavily indebted poor countries in 1977 to that in 1980?
Keep it short and to the point. 1. What is the ratio of the Waste generated(% of total energy) in High income: nonOECD in 1977 to that in 1980?
Provide a succinct answer. 1.32. What is the ratio of the Waste generated(% of total energy) of Kenya in 1977 to that in 1980?
Provide a short and direct response. 0.99. What is the ratio of the Waste generated(% of total energy) in Heavily indebted poor countries in 1978 to that in 1979?
Offer a terse response. 1. What is the ratio of the Waste generated(% of total energy) in High income: nonOECD in 1978 to that in 1979?
Your response must be concise. 1.18. What is the ratio of the Waste generated(% of total energy) of High income: nonOECD in 1978 to that in 1980?
Keep it short and to the point. 1.22. What is the ratio of the Waste generated(% of total energy) in Heavily indebted poor countries in 1979 to that in 1980?
Offer a very short reply. 1. What is the ratio of the Waste generated(% of total energy) of High income: nonOECD in 1979 to that in 1980?
Offer a terse response. 1.03. What is the ratio of the Waste generated(% of total energy) of Kenya in 1979 to that in 1980?
Your answer should be compact. 1. What is the difference between the highest and the second highest Waste generated(% of total energy) in Heavily indebted poor countries?
Keep it short and to the point. 0.2. What is the difference between the highest and the second highest Waste generated(% of total energy) of High income: nonOECD?
Your response must be concise. 0.14. What is the difference between the highest and the second highest Waste generated(% of total energy) of Kenya?
Provide a short and direct response. 0.84. What is the difference between the highest and the lowest Waste generated(% of total energy) of Heavily indebted poor countries?
Your answer should be very brief. 0.73. What is the difference between the highest and the lowest Waste generated(% of total energy) of High income: nonOECD?
Your answer should be compact. 1.39. What is the difference between the highest and the lowest Waste generated(% of total energy) in Kenya?
Offer a very short reply. 1.73. 